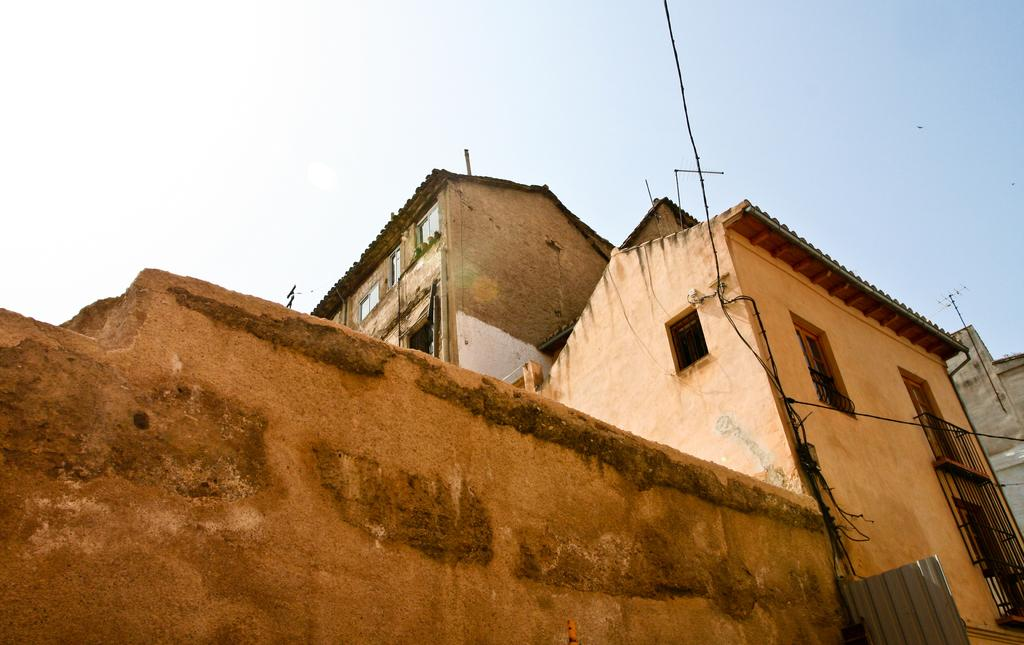What type of structure can be seen in the image? There is a wall in the image. Are there any other structures visible besides the wall? Yes, there are buildings in the image. What else can be seen in the image besides structures? There are wires in the image. What can be seen in the background of the image? The sky is visible in the background of the image. What color is the sofa in the image? There is no sofa present in the image. Can you describe the bone that is visible in the image? There is no bone present in the image. 